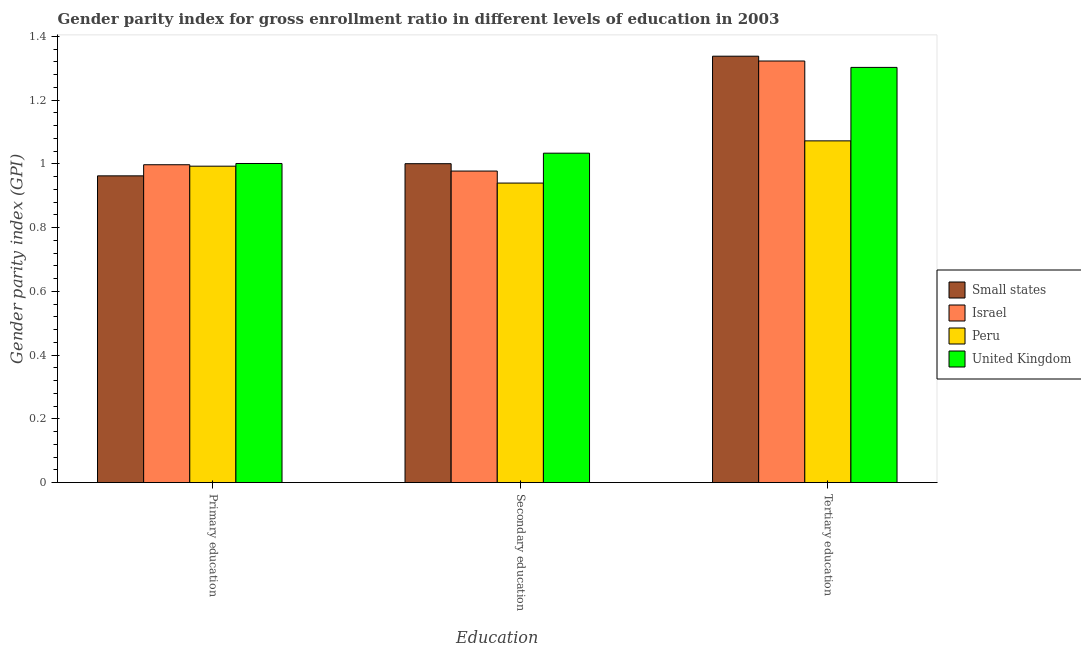How many different coloured bars are there?
Your response must be concise. 4. Are the number of bars on each tick of the X-axis equal?
Your answer should be very brief. Yes. How many bars are there on the 3rd tick from the right?
Provide a short and direct response. 4. What is the gender parity index in tertiary education in Small states?
Make the answer very short. 1.34. Across all countries, what is the maximum gender parity index in tertiary education?
Ensure brevity in your answer.  1.34. Across all countries, what is the minimum gender parity index in primary education?
Offer a terse response. 0.96. In which country was the gender parity index in secondary education maximum?
Provide a succinct answer. United Kingdom. In which country was the gender parity index in tertiary education minimum?
Your response must be concise. Peru. What is the total gender parity index in secondary education in the graph?
Provide a succinct answer. 3.95. What is the difference between the gender parity index in primary education in Peru and that in Small states?
Offer a terse response. 0.03. What is the difference between the gender parity index in primary education in United Kingdom and the gender parity index in tertiary education in Small states?
Give a very brief answer. -0.34. What is the average gender parity index in secondary education per country?
Provide a short and direct response. 0.99. What is the difference between the gender parity index in secondary education and gender parity index in primary education in United Kingdom?
Give a very brief answer. 0.03. In how many countries, is the gender parity index in primary education greater than 0.9600000000000001 ?
Your answer should be very brief. 4. What is the ratio of the gender parity index in secondary education in Israel to that in Peru?
Offer a terse response. 1.04. Is the gender parity index in primary education in Israel less than that in Peru?
Provide a succinct answer. No. Is the difference between the gender parity index in primary education in Peru and United Kingdom greater than the difference between the gender parity index in secondary education in Peru and United Kingdom?
Keep it short and to the point. Yes. What is the difference between the highest and the second highest gender parity index in primary education?
Your answer should be compact. 0. What is the difference between the highest and the lowest gender parity index in secondary education?
Give a very brief answer. 0.09. Is the sum of the gender parity index in primary education in United Kingdom and Small states greater than the maximum gender parity index in tertiary education across all countries?
Offer a terse response. Yes. How many bars are there?
Provide a succinct answer. 12. How many countries are there in the graph?
Provide a succinct answer. 4. Are the values on the major ticks of Y-axis written in scientific E-notation?
Your response must be concise. No. Does the graph contain grids?
Your response must be concise. No. How many legend labels are there?
Offer a very short reply. 4. What is the title of the graph?
Offer a terse response. Gender parity index for gross enrollment ratio in different levels of education in 2003. What is the label or title of the X-axis?
Provide a short and direct response. Education. What is the label or title of the Y-axis?
Provide a succinct answer. Gender parity index (GPI). What is the Gender parity index (GPI) of Small states in Primary education?
Your response must be concise. 0.96. What is the Gender parity index (GPI) in Israel in Primary education?
Make the answer very short. 1. What is the Gender parity index (GPI) in Peru in Primary education?
Your answer should be very brief. 0.99. What is the Gender parity index (GPI) of United Kingdom in Primary education?
Provide a short and direct response. 1. What is the Gender parity index (GPI) of Small states in Secondary education?
Offer a very short reply. 1. What is the Gender parity index (GPI) of Israel in Secondary education?
Give a very brief answer. 0.98. What is the Gender parity index (GPI) in Peru in Secondary education?
Offer a very short reply. 0.94. What is the Gender parity index (GPI) in United Kingdom in Secondary education?
Ensure brevity in your answer.  1.03. What is the Gender parity index (GPI) of Small states in Tertiary education?
Give a very brief answer. 1.34. What is the Gender parity index (GPI) in Israel in Tertiary education?
Your answer should be compact. 1.32. What is the Gender parity index (GPI) in Peru in Tertiary education?
Your answer should be compact. 1.07. What is the Gender parity index (GPI) of United Kingdom in Tertiary education?
Make the answer very short. 1.3. Across all Education, what is the maximum Gender parity index (GPI) in Small states?
Make the answer very short. 1.34. Across all Education, what is the maximum Gender parity index (GPI) of Israel?
Your response must be concise. 1.32. Across all Education, what is the maximum Gender parity index (GPI) of Peru?
Your answer should be compact. 1.07. Across all Education, what is the maximum Gender parity index (GPI) of United Kingdom?
Give a very brief answer. 1.3. Across all Education, what is the minimum Gender parity index (GPI) in Small states?
Your answer should be compact. 0.96. Across all Education, what is the minimum Gender parity index (GPI) of Israel?
Keep it short and to the point. 0.98. Across all Education, what is the minimum Gender parity index (GPI) in Peru?
Give a very brief answer. 0.94. Across all Education, what is the minimum Gender parity index (GPI) of United Kingdom?
Ensure brevity in your answer.  1. What is the total Gender parity index (GPI) in Small states in the graph?
Your answer should be very brief. 3.3. What is the total Gender parity index (GPI) in Israel in the graph?
Your response must be concise. 3.3. What is the total Gender parity index (GPI) of Peru in the graph?
Ensure brevity in your answer.  3.01. What is the total Gender parity index (GPI) of United Kingdom in the graph?
Your answer should be compact. 3.34. What is the difference between the Gender parity index (GPI) of Small states in Primary education and that in Secondary education?
Keep it short and to the point. -0.04. What is the difference between the Gender parity index (GPI) of Israel in Primary education and that in Secondary education?
Keep it short and to the point. 0.02. What is the difference between the Gender parity index (GPI) of Peru in Primary education and that in Secondary education?
Offer a terse response. 0.05. What is the difference between the Gender parity index (GPI) in United Kingdom in Primary education and that in Secondary education?
Your response must be concise. -0.03. What is the difference between the Gender parity index (GPI) of Small states in Primary education and that in Tertiary education?
Your answer should be compact. -0.38. What is the difference between the Gender parity index (GPI) in Israel in Primary education and that in Tertiary education?
Make the answer very short. -0.33. What is the difference between the Gender parity index (GPI) in Peru in Primary education and that in Tertiary education?
Your answer should be compact. -0.08. What is the difference between the Gender parity index (GPI) in United Kingdom in Primary education and that in Tertiary education?
Your answer should be compact. -0.3. What is the difference between the Gender parity index (GPI) of Small states in Secondary education and that in Tertiary education?
Offer a very short reply. -0.34. What is the difference between the Gender parity index (GPI) of Israel in Secondary education and that in Tertiary education?
Provide a short and direct response. -0.35. What is the difference between the Gender parity index (GPI) of Peru in Secondary education and that in Tertiary education?
Keep it short and to the point. -0.13. What is the difference between the Gender parity index (GPI) in United Kingdom in Secondary education and that in Tertiary education?
Your response must be concise. -0.27. What is the difference between the Gender parity index (GPI) in Small states in Primary education and the Gender parity index (GPI) in Israel in Secondary education?
Your answer should be compact. -0.02. What is the difference between the Gender parity index (GPI) in Small states in Primary education and the Gender parity index (GPI) in Peru in Secondary education?
Give a very brief answer. 0.02. What is the difference between the Gender parity index (GPI) in Small states in Primary education and the Gender parity index (GPI) in United Kingdom in Secondary education?
Provide a succinct answer. -0.07. What is the difference between the Gender parity index (GPI) in Israel in Primary education and the Gender parity index (GPI) in Peru in Secondary education?
Your answer should be very brief. 0.06. What is the difference between the Gender parity index (GPI) in Israel in Primary education and the Gender parity index (GPI) in United Kingdom in Secondary education?
Provide a short and direct response. -0.04. What is the difference between the Gender parity index (GPI) in Peru in Primary education and the Gender parity index (GPI) in United Kingdom in Secondary education?
Make the answer very short. -0.04. What is the difference between the Gender parity index (GPI) of Small states in Primary education and the Gender parity index (GPI) of Israel in Tertiary education?
Your answer should be compact. -0.36. What is the difference between the Gender parity index (GPI) in Small states in Primary education and the Gender parity index (GPI) in Peru in Tertiary education?
Offer a terse response. -0.11. What is the difference between the Gender parity index (GPI) in Small states in Primary education and the Gender parity index (GPI) in United Kingdom in Tertiary education?
Provide a short and direct response. -0.34. What is the difference between the Gender parity index (GPI) in Israel in Primary education and the Gender parity index (GPI) in Peru in Tertiary education?
Ensure brevity in your answer.  -0.07. What is the difference between the Gender parity index (GPI) of Israel in Primary education and the Gender parity index (GPI) of United Kingdom in Tertiary education?
Ensure brevity in your answer.  -0.31. What is the difference between the Gender parity index (GPI) of Peru in Primary education and the Gender parity index (GPI) of United Kingdom in Tertiary education?
Make the answer very short. -0.31. What is the difference between the Gender parity index (GPI) of Small states in Secondary education and the Gender parity index (GPI) of Israel in Tertiary education?
Give a very brief answer. -0.32. What is the difference between the Gender parity index (GPI) in Small states in Secondary education and the Gender parity index (GPI) in Peru in Tertiary education?
Your response must be concise. -0.07. What is the difference between the Gender parity index (GPI) of Small states in Secondary education and the Gender parity index (GPI) of United Kingdom in Tertiary education?
Provide a short and direct response. -0.3. What is the difference between the Gender parity index (GPI) in Israel in Secondary education and the Gender parity index (GPI) in Peru in Tertiary education?
Ensure brevity in your answer.  -0.09. What is the difference between the Gender parity index (GPI) in Israel in Secondary education and the Gender parity index (GPI) in United Kingdom in Tertiary education?
Make the answer very short. -0.33. What is the difference between the Gender parity index (GPI) in Peru in Secondary education and the Gender parity index (GPI) in United Kingdom in Tertiary education?
Offer a very short reply. -0.36. What is the average Gender parity index (GPI) of Small states per Education?
Your answer should be compact. 1.1. What is the average Gender parity index (GPI) in Israel per Education?
Offer a very short reply. 1.1. What is the average Gender parity index (GPI) of United Kingdom per Education?
Give a very brief answer. 1.11. What is the difference between the Gender parity index (GPI) in Small states and Gender parity index (GPI) in Israel in Primary education?
Offer a terse response. -0.03. What is the difference between the Gender parity index (GPI) in Small states and Gender parity index (GPI) in Peru in Primary education?
Your answer should be compact. -0.03. What is the difference between the Gender parity index (GPI) in Small states and Gender parity index (GPI) in United Kingdom in Primary education?
Keep it short and to the point. -0.04. What is the difference between the Gender parity index (GPI) of Israel and Gender parity index (GPI) of Peru in Primary education?
Offer a very short reply. 0. What is the difference between the Gender parity index (GPI) in Israel and Gender parity index (GPI) in United Kingdom in Primary education?
Your answer should be very brief. -0. What is the difference between the Gender parity index (GPI) in Peru and Gender parity index (GPI) in United Kingdom in Primary education?
Ensure brevity in your answer.  -0.01. What is the difference between the Gender parity index (GPI) of Small states and Gender parity index (GPI) of Israel in Secondary education?
Provide a succinct answer. 0.02. What is the difference between the Gender parity index (GPI) of Small states and Gender parity index (GPI) of Peru in Secondary education?
Ensure brevity in your answer.  0.06. What is the difference between the Gender parity index (GPI) of Small states and Gender parity index (GPI) of United Kingdom in Secondary education?
Give a very brief answer. -0.03. What is the difference between the Gender parity index (GPI) in Israel and Gender parity index (GPI) in Peru in Secondary education?
Offer a terse response. 0.04. What is the difference between the Gender parity index (GPI) of Israel and Gender parity index (GPI) of United Kingdom in Secondary education?
Your answer should be very brief. -0.06. What is the difference between the Gender parity index (GPI) in Peru and Gender parity index (GPI) in United Kingdom in Secondary education?
Your response must be concise. -0.09. What is the difference between the Gender parity index (GPI) in Small states and Gender parity index (GPI) in Israel in Tertiary education?
Offer a very short reply. 0.02. What is the difference between the Gender parity index (GPI) in Small states and Gender parity index (GPI) in Peru in Tertiary education?
Make the answer very short. 0.27. What is the difference between the Gender parity index (GPI) in Small states and Gender parity index (GPI) in United Kingdom in Tertiary education?
Your answer should be very brief. 0.04. What is the difference between the Gender parity index (GPI) of Israel and Gender parity index (GPI) of Peru in Tertiary education?
Your answer should be very brief. 0.25. What is the difference between the Gender parity index (GPI) in Israel and Gender parity index (GPI) in United Kingdom in Tertiary education?
Provide a short and direct response. 0.02. What is the difference between the Gender parity index (GPI) of Peru and Gender parity index (GPI) of United Kingdom in Tertiary education?
Give a very brief answer. -0.23. What is the ratio of the Gender parity index (GPI) of Small states in Primary education to that in Secondary education?
Offer a very short reply. 0.96. What is the ratio of the Gender parity index (GPI) in Israel in Primary education to that in Secondary education?
Keep it short and to the point. 1.02. What is the ratio of the Gender parity index (GPI) of Peru in Primary education to that in Secondary education?
Your response must be concise. 1.06. What is the ratio of the Gender parity index (GPI) of United Kingdom in Primary education to that in Secondary education?
Ensure brevity in your answer.  0.97. What is the ratio of the Gender parity index (GPI) of Small states in Primary education to that in Tertiary education?
Ensure brevity in your answer.  0.72. What is the ratio of the Gender parity index (GPI) of Israel in Primary education to that in Tertiary education?
Your response must be concise. 0.75. What is the ratio of the Gender parity index (GPI) in Peru in Primary education to that in Tertiary education?
Your answer should be compact. 0.93. What is the ratio of the Gender parity index (GPI) of United Kingdom in Primary education to that in Tertiary education?
Provide a short and direct response. 0.77. What is the ratio of the Gender parity index (GPI) of Small states in Secondary education to that in Tertiary education?
Offer a very short reply. 0.75. What is the ratio of the Gender parity index (GPI) in Israel in Secondary education to that in Tertiary education?
Offer a terse response. 0.74. What is the ratio of the Gender parity index (GPI) of Peru in Secondary education to that in Tertiary education?
Your response must be concise. 0.88. What is the ratio of the Gender parity index (GPI) in United Kingdom in Secondary education to that in Tertiary education?
Make the answer very short. 0.79. What is the difference between the highest and the second highest Gender parity index (GPI) of Small states?
Your answer should be very brief. 0.34. What is the difference between the highest and the second highest Gender parity index (GPI) of Israel?
Your answer should be very brief. 0.33. What is the difference between the highest and the second highest Gender parity index (GPI) of Peru?
Offer a very short reply. 0.08. What is the difference between the highest and the second highest Gender parity index (GPI) of United Kingdom?
Make the answer very short. 0.27. What is the difference between the highest and the lowest Gender parity index (GPI) of Small states?
Keep it short and to the point. 0.38. What is the difference between the highest and the lowest Gender parity index (GPI) of Israel?
Your response must be concise. 0.35. What is the difference between the highest and the lowest Gender parity index (GPI) in Peru?
Keep it short and to the point. 0.13. What is the difference between the highest and the lowest Gender parity index (GPI) in United Kingdom?
Offer a very short reply. 0.3. 